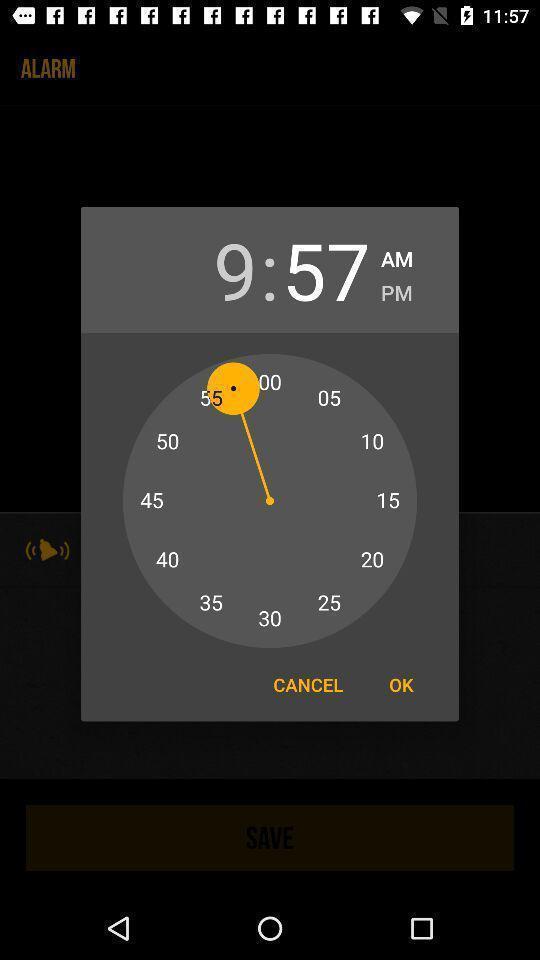What details can you identify in this image? Popup of analog timer with buttons. 